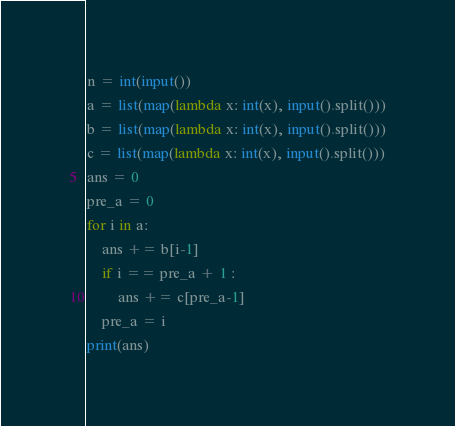Convert code to text. <code><loc_0><loc_0><loc_500><loc_500><_Python_>n = int(input())
a = list(map(lambda x: int(x), input().split()))
b = list(map(lambda x: int(x), input().split()))
c = list(map(lambda x: int(x), input().split()))
ans = 0
pre_a = 0
for i in a:
    ans += b[i-1]
    if i == pre_a + 1 :
        ans += c[pre_a-1]
    pre_a = i
print(ans)
</code> 